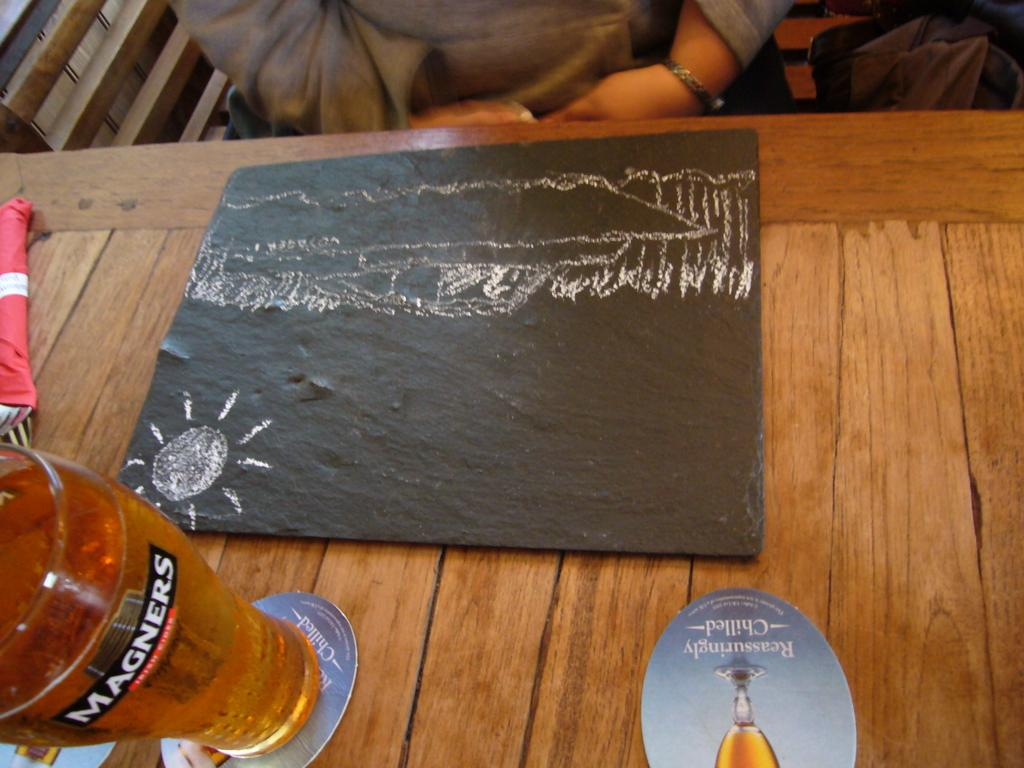<image>
Write a terse but informative summary of the picture. A full glass that has Magners written on it. 